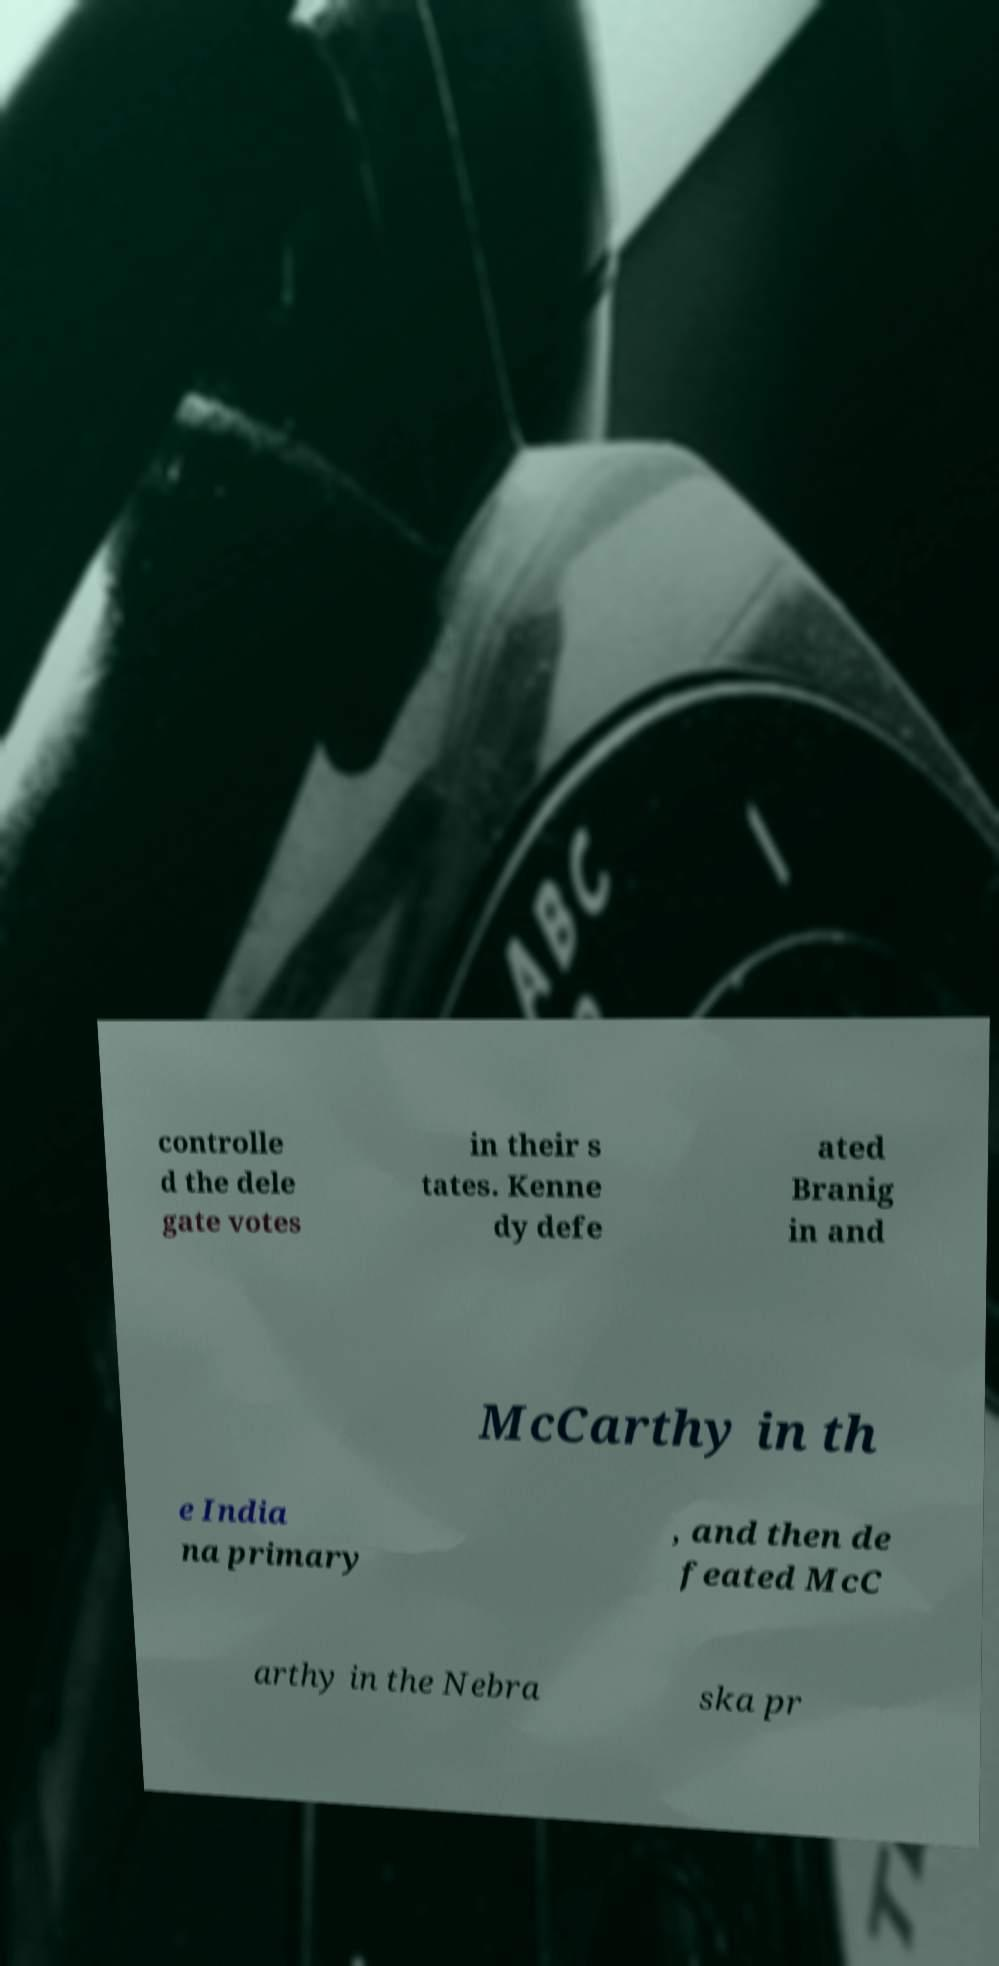Can you accurately transcribe the text from the provided image for me? controlle d the dele gate votes in their s tates. Kenne dy defe ated Branig in and McCarthy in th e India na primary , and then de feated McC arthy in the Nebra ska pr 